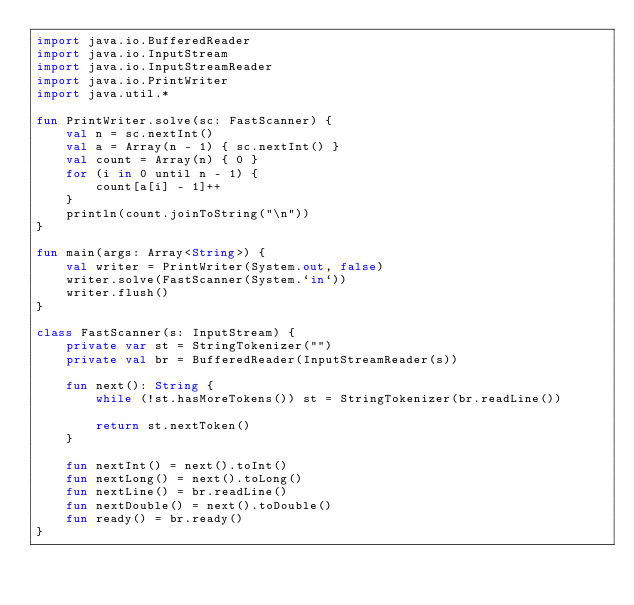<code> <loc_0><loc_0><loc_500><loc_500><_Kotlin_>import java.io.BufferedReader
import java.io.InputStream
import java.io.InputStreamReader
import java.io.PrintWriter
import java.util.*

fun PrintWriter.solve(sc: FastScanner) {
    val n = sc.nextInt()
    val a = Array(n - 1) { sc.nextInt() }
    val count = Array(n) { 0 }
    for (i in 0 until n - 1) {
        count[a[i] - 1]++
    }
    println(count.joinToString("\n"))
}

fun main(args: Array<String>) {
    val writer = PrintWriter(System.out, false)
    writer.solve(FastScanner(System.`in`))
    writer.flush()
}

class FastScanner(s: InputStream) {
    private var st = StringTokenizer("")
    private val br = BufferedReader(InputStreamReader(s))

    fun next(): String {
        while (!st.hasMoreTokens()) st = StringTokenizer(br.readLine())

        return st.nextToken()
    }

    fun nextInt() = next().toInt()
    fun nextLong() = next().toLong()
    fun nextLine() = br.readLine()
    fun nextDouble() = next().toDouble()
    fun ready() = br.ready()
}
</code> 